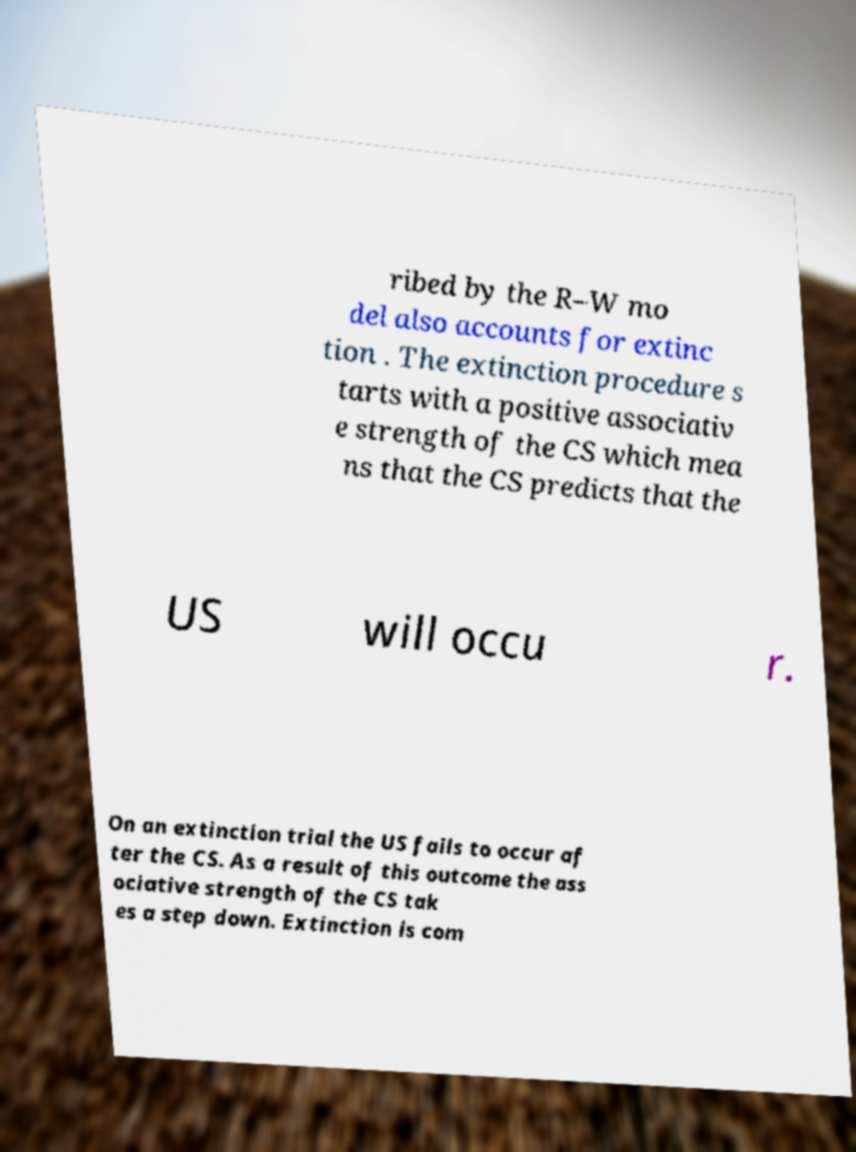What messages or text are displayed in this image? I need them in a readable, typed format. ribed by the R–W mo del also accounts for extinc tion . The extinction procedure s tarts with a positive associativ e strength of the CS which mea ns that the CS predicts that the US will occu r. On an extinction trial the US fails to occur af ter the CS. As a result of this outcome the ass ociative strength of the CS tak es a step down. Extinction is com 